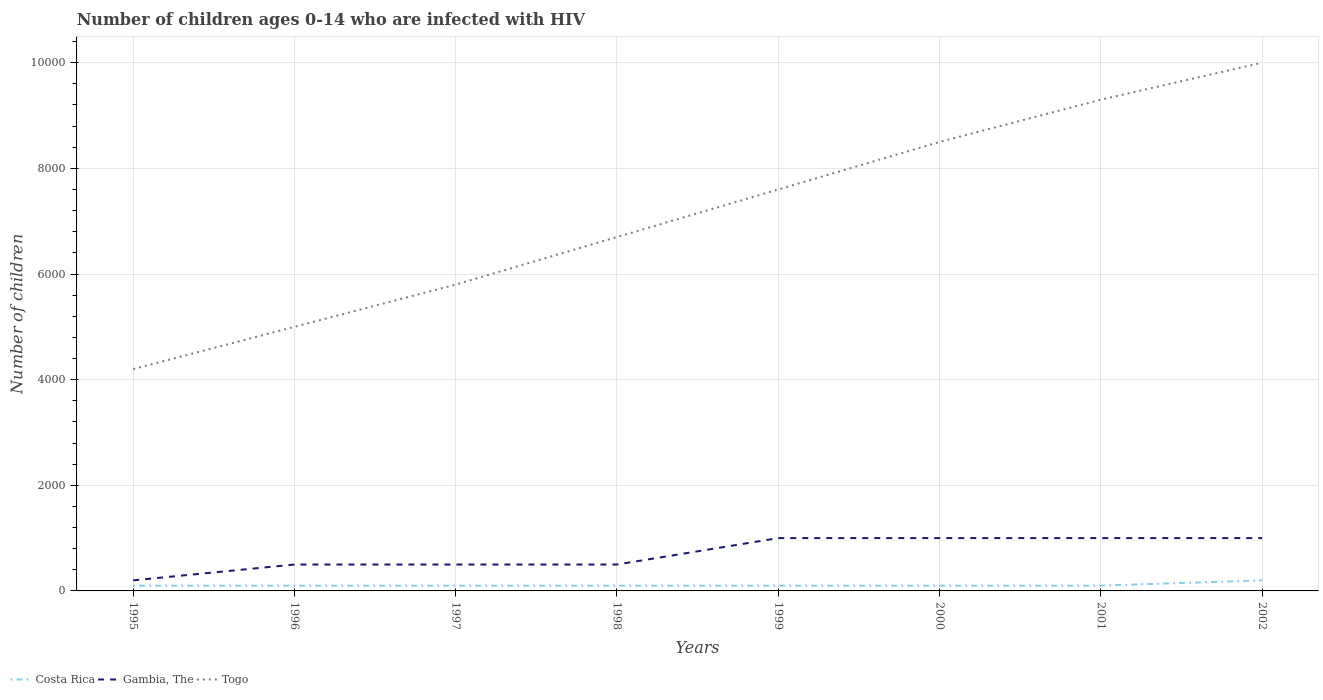How many different coloured lines are there?
Provide a succinct answer. 3. Does the line corresponding to Togo intersect with the line corresponding to Gambia, The?
Give a very brief answer. No. Is the number of lines equal to the number of legend labels?
Provide a short and direct response. Yes. Across all years, what is the maximum number of HIV infected children in Gambia, The?
Offer a very short reply. 200. What is the total number of HIV infected children in Gambia, The in the graph?
Offer a terse response. -300. What is the difference between the highest and the second highest number of HIV infected children in Costa Rica?
Keep it short and to the point. 100. Is the number of HIV infected children in Gambia, The strictly greater than the number of HIV infected children in Togo over the years?
Offer a very short reply. Yes. How many years are there in the graph?
Give a very brief answer. 8. Are the values on the major ticks of Y-axis written in scientific E-notation?
Provide a succinct answer. No. Does the graph contain any zero values?
Provide a short and direct response. No. Does the graph contain grids?
Make the answer very short. Yes. Where does the legend appear in the graph?
Keep it short and to the point. Bottom left. How many legend labels are there?
Make the answer very short. 3. How are the legend labels stacked?
Offer a very short reply. Horizontal. What is the title of the graph?
Ensure brevity in your answer.  Number of children ages 0-14 who are infected with HIV. What is the label or title of the Y-axis?
Ensure brevity in your answer.  Number of children. What is the Number of children in Togo in 1995?
Give a very brief answer. 4200. What is the Number of children of Costa Rica in 1996?
Provide a short and direct response. 100. What is the Number of children in Togo in 1996?
Make the answer very short. 5000. What is the Number of children of Togo in 1997?
Give a very brief answer. 5800. What is the Number of children of Costa Rica in 1998?
Your answer should be compact. 100. What is the Number of children of Gambia, The in 1998?
Provide a short and direct response. 500. What is the Number of children of Togo in 1998?
Your answer should be compact. 6700. What is the Number of children in Costa Rica in 1999?
Your response must be concise. 100. What is the Number of children of Gambia, The in 1999?
Keep it short and to the point. 1000. What is the Number of children of Togo in 1999?
Provide a succinct answer. 7600. What is the Number of children in Costa Rica in 2000?
Keep it short and to the point. 100. What is the Number of children in Gambia, The in 2000?
Offer a terse response. 1000. What is the Number of children of Togo in 2000?
Ensure brevity in your answer.  8500. What is the Number of children in Costa Rica in 2001?
Your answer should be very brief. 100. What is the Number of children in Togo in 2001?
Your response must be concise. 9300. What is the Number of children in Gambia, The in 2002?
Offer a terse response. 1000. Across all years, what is the maximum Number of children in Gambia, The?
Provide a short and direct response. 1000. Across all years, what is the maximum Number of children in Togo?
Ensure brevity in your answer.  10000. Across all years, what is the minimum Number of children of Costa Rica?
Provide a short and direct response. 100. Across all years, what is the minimum Number of children in Gambia, The?
Offer a terse response. 200. Across all years, what is the minimum Number of children in Togo?
Give a very brief answer. 4200. What is the total Number of children of Costa Rica in the graph?
Offer a very short reply. 900. What is the total Number of children in Gambia, The in the graph?
Offer a very short reply. 5700. What is the total Number of children in Togo in the graph?
Give a very brief answer. 5.71e+04. What is the difference between the Number of children of Gambia, The in 1995 and that in 1996?
Your answer should be very brief. -300. What is the difference between the Number of children in Togo in 1995 and that in 1996?
Your answer should be compact. -800. What is the difference between the Number of children in Costa Rica in 1995 and that in 1997?
Provide a succinct answer. 0. What is the difference between the Number of children in Gambia, The in 1995 and that in 1997?
Keep it short and to the point. -300. What is the difference between the Number of children in Togo in 1995 and that in 1997?
Offer a terse response. -1600. What is the difference between the Number of children in Gambia, The in 1995 and that in 1998?
Provide a short and direct response. -300. What is the difference between the Number of children in Togo in 1995 and that in 1998?
Keep it short and to the point. -2500. What is the difference between the Number of children in Costa Rica in 1995 and that in 1999?
Ensure brevity in your answer.  0. What is the difference between the Number of children in Gambia, The in 1995 and that in 1999?
Your answer should be compact. -800. What is the difference between the Number of children of Togo in 1995 and that in 1999?
Offer a very short reply. -3400. What is the difference between the Number of children in Costa Rica in 1995 and that in 2000?
Offer a terse response. 0. What is the difference between the Number of children of Gambia, The in 1995 and that in 2000?
Your response must be concise. -800. What is the difference between the Number of children of Togo in 1995 and that in 2000?
Provide a short and direct response. -4300. What is the difference between the Number of children in Costa Rica in 1995 and that in 2001?
Give a very brief answer. 0. What is the difference between the Number of children of Gambia, The in 1995 and that in 2001?
Your answer should be compact. -800. What is the difference between the Number of children of Togo in 1995 and that in 2001?
Your response must be concise. -5100. What is the difference between the Number of children of Costa Rica in 1995 and that in 2002?
Make the answer very short. -100. What is the difference between the Number of children of Gambia, The in 1995 and that in 2002?
Make the answer very short. -800. What is the difference between the Number of children in Togo in 1995 and that in 2002?
Offer a very short reply. -5800. What is the difference between the Number of children in Costa Rica in 1996 and that in 1997?
Make the answer very short. 0. What is the difference between the Number of children of Gambia, The in 1996 and that in 1997?
Make the answer very short. 0. What is the difference between the Number of children in Togo in 1996 and that in 1997?
Ensure brevity in your answer.  -800. What is the difference between the Number of children in Costa Rica in 1996 and that in 1998?
Offer a very short reply. 0. What is the difference between the Number of children of Togo in 1996 and that in 1998?
Make the answer very short. -1700. What is the difference between the Number of children of Costa Rica in 1996 and that in 1999?
Provide a succinct answer. 0. What is the difference between the Number of children in Gambia, The in 1996 and that in 1999?
Keep it short and to the point. -500. What is the difference between the Number of children in Togo in 1996 and that in 1999?
Your answer should be very brief. -2600. What is the difference between the Number of children in Costa Rica in 1996 and that in 2000?
Offer a terse response. 0. What is the difference between the Number of children of Gambia, The in 1996 and that in 2000?
Ensure brevity in your answer.  -500. What is the difference between the Number of children in Togo in 1996 and that in 2000?
Your answer should be compact. -3500. What is the difference between the Number of children of Gambia, The in 1996 and that in 2001?
Provide a short and direct response. -500. What is the difference between the Number of children of Togo in 1996 and that in 2001?
Provide a short and direct response. -4300. What is the difference between the Number of children of Costa Rica in 1996 and that in 2002?
Provide a short and direct response. -100. What is the difference between the Number of children of Gambia, The in 1996 and that in 2002?
Make the answer very short. -500. What is the difference between the Number of children in Togo in 1996 and that in 2002?
Your response must be concise. -5000. What is the difference between the Number of children in Togo in 1997 and that in 1998?
Make the answer very short. -900. What is the difference between the Number of children of Gambia, The in 1997 and that in 1999?
Your answer should be very brief. -500. What is the difference between the Number of children of Togo in 1997 and that in 1999?
Make the answer very short. -1800. What is the difference between the Number of children of Costa Rica in 1997 and that in 2000?
Make the answer very short. 0. What is the difference between the Number of children in Gambia, The in 1997 and that in 2000?
Provide a succinct answer. -500. What is the difference between the Number of children in Togo in 1997 and that in 2000?
Provide a succinct answer. -2700. What is the difference between the Number of children in Costa Rica in 1997 and that in 2001?
Offer a very short reply. 0. What is the difference between the Number of children of Gambia, The in 1997 and that in 2001?
Ensure brevity in your answer.  -500. What is the difference between the Number of children of Togo in 1997 and that in 2001?
Your answer should be very brief. -3500. What is the difference between the Number of children in Costa Rica in 1997 and that in 2002?
Your answer should be compact. -100. What is the difference between the Number of children in Gambia, The in 1997 and that in 2002?
Keep it short and to the point. -500. What is the difference between the Number of children of Togo in 1997 and that in 2002?
Provide a succinct answer. -4200. What is the difference between the Number of children in Gambia, The in 1998 and that in 1999?
Give a very brief answer. -500. What is the difference between the Number of children of Togo in 1998 and that in 1999?
Your response must be concise. -900. What is the difference between the Number of children in Gambia, The in 1998 and that in 2000?
Your answer should be compact. -500. What is the difference between the Number of children of Togo in 1998 and that in 2000?
Give a very brief answer. -1800. What is the difference between the Number of children in Gambia, The in 1998 and that in 2001?
Provide a succinct answer. -500. What is the difference between the Number of children of Togo in 1998 and that in 2001?
Provide a short and direct response. -2600. What is the difference between the Number of children of Costa Rica in 1998 and that in 2002?
Give a very brief answer. -100. What is the difference between the Number of children in Gambia, The in 1998 and that in 2002?
Provide a short and direct response. -500. What is the difference between the Number of children in Togo in 1998 and that in 2002?
Your response must be concise. -3300. What is the difference between the Number of children of Costa Rica in 1999 and that in 2000?
Keep it short and to the point. 0. What is the difference between the Number of children of Togo in 1999 and that in 2000?
Make the answer very short. -900. What is the difference between the Number of children of Costa Rica in 1999 and that in 2001?
Ensure brevity in your answer.  0. What is the difference between the Number of children in Togo in 1999 and that in 2001?
Make the answer very short. -1700. What is the difference between the Number of children of Costa Rica in 1999 and that in 2002?
Make the answer very short. -100. What is the difference between the Number of children in Gambia, The in 1999 and that in 2002?
Your response must be concise. 0. What is the difference between the Number of children of Togo in 1999 and that in 2002?
Provide a succinct answer. -2400. What is the difference between the Number of children in Gambia, The in 2000 and that in 2001?
Make the answer very short. 0. What is the difference between the Number of children of Togo in 2000 and that in 2001?
Your answer should be compact. -800. What is the difference between the Number of children in Costa Rica in 2000 and that in 2002?
Give a very brief answer. -100. What is the difference between the Number of children of Togo in 2000 and that in 2002?
Offer a terse response. -1500. What is the difference between the Number of children of Costa Rica in 2001 and that in 2002?
Ensure brevity in your answer.  -100. What is the difference between the Number of children in Togo in 2001 and that in 2002?
Offer a very short reply. -700. What is the difference between the Number of children in Costa Rica in 1995 and the Number of children in Gambia, The in 1996?
Your answer should be compact. -400. What is the difference between the Number of children in Costa Rica in 1995 and the Number of children in Togo in 1996?
Provide a short and direct response. -4900. What is the difference between the Number of children of Gambia, The in 1995 and the Number of children of Togo in 1996?
Offer a terse response. -4800. What is the difference between the Number of children in Costa Rica in 1995 and the Number of children in Gambia, The in 1997?
Offer a terse response. -400. What is the difference between the Number of children of Costa Rica in 1995 and the Number of children of Togo in 1997?
Make the answer very short. -5700. What is the difference between the Number of children of Gambia, The in 1995 and the Number of children of Togo in 1997?
Offer a terse response. -5600. What is the difference between the Number of children in Costa Rica in 1995 and the Number of children in Gambia, The in 1998?
Keep it short and to the point. -400. What is the difference between the Number of children in Costa Rica in 1995 and the Number of children in Togo in 1998?
Your answer should be very brief. -6600. What is the difference between the Number of children in Gambia, The in 1995 and the Number of children in Togo in 1998?
Your answer should be compact. -6500. What is the difference between the Number of children of Costa Rica in 1995 and the Number of children of Gambia, The in 1999?
Your answer should be very brief. -900. What is the difference between the Number of children of Costa Rica in 1995 and the Number of children of Togo in 1999?
Keep it short and to the point. -7500. What is the difference between the Number of children of Gambia, The in 1995 and the Number of children of Togo in 1999?
Provide a succinct answer. -7400. What is the difference between the Number of children of Costa Rica in 1995 and the Number of children of Gambia, The in 2000?
Make the answer very short. -900. What is the difference between the Number of children in Costa Rica in 1995 and the Number of children in Togo in 2000?
Make the answer very short. -8400. What is the difference between the Number of children in Gambia, The in 1995 and the Number of children in Togo in 2000?
Keep it short and to the point. -8300. What is the difference between the Number of children of Costa Rica in 1995 and the Number of children of Gambia, The in 2001?
Your response must be concise. -900. What is the difference between the Number of children in Costa Rica in 1995 and the Number of children in Togo in 2001?
Provide a succinct answer. -9200. What is the difference between the Number of children in Gambia, The in 1995 and the Number of children in Togo in 2001?
Make the answer very short. -9100. What is the difference between the Number of children in Costa Rica in 1995 and the Number of children in Gambia, The in 2002?
Make the answer very short. -900. What is the difference between the Number of children of Costa Rica in 1995 and the Number of children of Togo in 2002?
Ensure brevity in your answer.  -9900. What is the difference between the Number of children of Gambia, The in 1995 and the Number of children of Togo in 2002?
Your response must be concise. -9800. What is the difference between the Number of children of Costa Rica in 1996 and the Number of children of Gambia, The in 1997?
Provide a succinct answer. -400. What is the difference between the Number of children in Costa Rica in 1996 and the Number of children in Togo in 1997?
Your answer should be very brief. -5700. What is the difference between the Number of children of Gambia, The in 1996 and the Number of children of Togo in 1997?
Keep it short and to the point. -5300. What is the difference between the Number of children of Costa Rica in 1996 and the Number of children of Gambia, The in 1998?
Provide a succinct answer. -400. What is the difference between the Number of children of Costa Rica in 1996 and the Number of children of Togo in 1998?
Make the answer very short. -6600. What is the difference between the Number of children in Gambia, The in 1996 and the Number of children in Togo in 1998?
Ensure brevity in your answer.  -6200. What is the difference between the Number of children in Costa Rica in 1996 and the Number of children in Gambia, The in 1999?
Keep it short and to the point. -900. What is the difference between the Number of children of Costa Rica in 1996 and the Number of children of Togo in 1999?
Your response must be concise. -7500. What is the difference between the Number of children in Gambia, The in 1996 and the Number of children in Togo in 1999?
Give a very brief answer. -7100. What is the difference between the Number of children in Costa Rica in 1996 and the Number of children in Gambia, The in 2000?
Offer a terse response. -900. What is the difference between the Number of children in Costa Rica in 1996 and the Number of children in Togo in 2000?
Provide a succinct answer. -8400. What is the difference between the Number of children in Gambia, The in 1996 and the Number of children in Togo in 2000?
Your answer should be very brief. -8000. What is the difference between the Number of children of Costa Rica in 1996 and the Number of children of Gambia, The in 2001?
Make the answer very short. -900. What is the difference between the Number of children of Costa Rica in 1996 and the Number of children of Togo in 2001?
Your answer should be compact. -9200. What is the difference between the Number of children of Gambia, The in 1996 and the Number of children of Togo in 2001?
Your response must be concise. -8800. What is the difference between the Number of children in Costa Rica in 1996 and the Number of children in Gambia, The in 2002?
Offer a terse response. -900. What is the difference between the Number of children in Costa Rica in 1996 and the Number of children in Togo in 2002?
Ensure brevity in your answer.  -9900. What is the difference between the Number of children of Gambia, The in 1996 and the Number of children of Togo in 2002?
Ensure brevity in your answer.  -9500. What is the difference between the Number of children in Costa Rica in 1997 and the Number of children in Gambia, The in 1998?
Give a very brief answer. -400. What is the difference between the Number of children in Costa Rica in 1997 and the Number of children in Togo in 1998?
Make the answer very short. -6600. What is the difference between the Number of children in Gambia, The in 1997 and the Number of children in Togo in 1998?
Provide a succinct answer. -6200. What is the difference between the Number of children in Costa Rica in 1997 and the Number of children in Gambia, The in 1999?
Offer a terse response. -900. What is the difference between the Number of children in Costa Rica in 1997 and the Number of children in Togo in 1999?
Provide a short and direct response. -7500. What is the difference between the Number of children in Gambia, The in 1997 and the Number of children in Togo in 1999?
Your answer should be very brief. -7100. What is the difference between the Number of children of Costa Rica in 1997 and the Number of children of Gambia, The in 2000?
Provide a succinct answer. -900. What is the difference between the Number of children in Costa Rica in 1997 and the Number of children in Togo in 2000?
Your response must be concise. -8400. What is the difference between the Number of children in Gambia, The in 1997 and the Number of children in Togo in 2000?
Give a very brief answer. -8000. What is the difference between the Number of children in Costa Rica in 1997 and the Number of children in Gambia, The in 2001?
Keep it short and to the point. -900. What is the difference between the Number of children of Costa Rica in 1997 and the Number of children of Togo in 2001?
Your answer should be very brief. -9200. What is the difference between the Number of children in Gambia, The in 1997 and the Number of children in Togo in 2001?
Ensure brevity in your answer.  -8800. What is the difference between the Number of children of Costa Rica in 1997 and the Number of children of Gambia, The in 2002?
Keep it short and to the point. -900. What is the difference between the Number of children of Costa Rica in 1997 and the Number of children of Togo in 2002?
Offer a terse response. -9900. What is the difference between the Number of children of Gambia, The in 1997 and the Number of children of Togo in 2002?
Your answer should be very brief. -9500. What is the difference between the Number of children in Costa Rica in 1998 and the Number of children in Gambia, The in 1999?
Keep it short and to the point. -900. What is the difference between the Number of children in Costa Rica in 1998 and the Number of children in Togo in 1999?
Provide a short and direct response. -7500. What is the difference between the Number of children of Gambia, The in 1998 and the Number of children of Togo in 1999?
Ensure brevity in your answer.  -7100. What is the difference between the Number of children of Costa Rica in 1998 and the Number of children of Gambia, The in 2000?
Provide a succinct answer. -900. What is the difference between the Number of children in Costa Rica in 1998 and the Number of children in Togo in 2000?
Offer a very short reply. -8400. What is the difference between the Number of children of Gambia, The in 1998 and the Number of children of Togo in 2000?
Provide a succinct answer. -8000. What is the difference between the Number of children of Costa Rica in 1998 and the Number of children of Gambia, The in 2001?
Offer a very short reply. -900. What is the difference between the Number of children of Costa Rica in 1998 and the Number of children of Togo in 2001?
Make the answer very short. -9200. What is the difference between the Number of children in Gambia, The in 1998 and the Number of children in Togo in 2001?
Your answer should be compact. -8800. What is the difference between the Number of children in Costa Rica in 1998 and the Number of children in Gambia, The in 2002?
Provide a short and direct response. -900. What is the difference between the Number of children of Costa Rica in 1998 and the Number of children of Togo in 2002?
Give a very brief answer. -9900. What is the difference between the Number of children in Gambia, The in 1998 and the Number of children in Togo in 2002?
Keep it short and to the point. -9500. What is the difference between the Number of children of Costa Rica in 1999 and the Number of children of Gambia, The in 2000?
Your answer should be very brief. -900. What is the difference between the Number of children of Costa Rica in 1999 and the Number of children of Togo in 2000?
Ensure brevity in your answer.  -8400. What is the difference between the Number of children of Gambia, The in 1999 and the Number of children of Togo in 2000?
Offer a terse response. -7500. What is the difference between the Number of children in Costa Rica in 1999 and the Number of children in Gambia, The in 2001?
Offer a terse response. -900. What is the difference between the Number of children in Costa Rica in 1999 and the Number of children in Togo in 2001?
Keep it short and to the point. -9200. What is the difference between the Number of children in Gambia, The in 1999 and the Number of children in Togo in 2001?
Ensure brevity in your answer.  -8300. What is the difference between the Number of children in Costa Rica in 1999 and the Number of children in Gambia, The in 2002?
Your answer should be compact. -900. What is the difference between the Number of children in Costa Rica in 1999 and the Number of children in Togo in 2002?
Ensure brevity in your answer.  -9900. What is the difference between the Number of children of Gambia, The in 1999 and the Number of children of Togo in 2002?
Your answer should be compact. -9000. What is the difference between the Number of children in Costa Rica in 2000 and the Number of children in Gambia, The in 2001?
Give a very brief answer. -900. What is the difference between the Number of children in Costa Rica in 2000 and the Number of children in Togo in 2001?
Offer a terse response. -9200. What is the difference between the Number of children of Gambia, The in 2000 and the Number of children of Togo in 2001?
Offer a terse response. -8300. What is the difference between the Number of children in Costa Rica in 2000 and the Number of children in Gambia, The in 2002?
Provide a succinct answer. -900. What is the difference between the Number of children of Costa Rica in 2000 and the Number of children of Togo in 2002?
Ensure brevity in your answer.  -9900. What is the difference between the Number of children of Gambia, The in 2000 and the Number of children of Togo in 2002?
Give a very brief answer. -9000. What is the difference between the Number of children of Costa Rica in 2001 and the Number of children of Gambia, The in 2002?
Offer a terse response. -900. What is the difference between the Number of children of Costa Rica in 2001 and the Number of children of Togo in 2002?
Provide a short and direct response. -9900. What is the difference between the Number of children of Gambia, The in 2001 and the Number of children of Togo in 2002?
Give a very brief answer. -9000. What is the average Number of children in Costa Rica per year?
Offer a very short reply. 112.5. What is the average Number of children in Gambia, The per year?
Provide a succinct answer. 712.5. What is the average Number of children in Togo per year?
Offer a terse response. 7137.5. In the year 1995, what is the difference between the Number of children in Costa Rica and Number of children in Gambia, The?
Ensure brevity in your answer.  -100. In the year 1995, what is the difference between the Number of children of Costa Rica and Number of children of Togo?
Provide a short and direct response. -4100. In the year 1995, what is the difference between the Number of children in Gambia, The and Number of children in Togo?
Keep it short and to the point. -4000. In the year 1996, what is the difference between the Number of children of Costa Rica and Number of children of Gambia, The?
Keep it short and to the point. -400. In the year 1996, what is the difference between the Number of children in Costa Rica and Number of children in Togo?
Provide a succinct answer. -4900. In the year 1996, what is the difference between the Number of children of Gambia, The and Number of children of Togo?
Make the answer very short. -4500. In the year 1997, what is the difference between the Number of children in Costa Rica and Number of children in Gambia, The?
Your answer should be compact. -400. In the year 1997, what is the difference between the Number of children in Costa Rica and Number of children in Togo?
Make the answer very short. -5700. In the year 1997, what is the difference between the Number of children of Gambia, The and Number of children of Togo?
Provide a succinct answer. -5300. In the year 1998, what is the difference between the Number of children of Costa Rica and Number of children of Gambia, The?
Keep it short and to the point. -400. In the year 1998, what is the difference between the Number of children in Costa Rica and Number of children in Togo?
Provide a short and direct response. -6600. In the year 1998, what is the difference between the Number of children in Gambia, The and Number of children in Togo?
Offer a very short reply. -6200. In the year 1999, what is the difference between the Number of children in Costa Rica and Number of children in Gambia, The?
Your response must be concise. -900. In the year 1999, what is the difference between the Number of children of Costa Rica and Number of children of Togo?
Offer a terse response. -7500. In the year 1999, what is the difference between the Number of children in Gambia, The and Number of children in Togo?
Make the answer very short. -6600. In the year 2000, what is the difference between the Number of children of Costa Rica and Number of children of Gambia, The?
Make the answer very short. -900. In the year 2000, what is the difference between the Number of children in Costa Rica and Number of children in Togo?
Offer a very short reply. -8400. In the year 2000, what is the difference between the Number of children of Gambia, The and Number of children of Togo?
Provide a short and direct response. -7500. In the year 2001, what is the difference between the Number of children in Costa Rica and Number of children in Gambia, The?
Keep it short and to the point. -900. In the year 2001, what is the difference between the Number of children in Costa Rica and Number of children in Togo?
Provide a short and direct response. -9200. In the year 2001, what is the difference between the Number of children in Gambia, The and Number of children in Togo?
Offer a terse response. -8300. In the year 2002, what is the difference between the Number of children of Costa Rica and Number of children of Gambia, The?
Give a very brief answer. -800. In the year 2002, what is the difference between the Number of children in Costa Rica and Number of children in Togo?
Give a very brief answer. -9800. In the year 2002, what is the difference between the Number of children of Gambia, The and Number of children of Togo?
Your response must be concise. -9000. What is the ratio of the Number of children in Costa Rica in 1995 to that in 1996?
Offer a terse response. 1. What is the ratio of the Number of children of Gambia, The in 1995 to that in 1996?
Offer a very short reply. 0.4. What is the ratio of the Number of children in Togo in 1995 to that in 1996?
Keep it short and to the point. 0.84. What is the ratio of the Number of children in Costa Rica in 1995 to that in 1997?
Ensure brevity in your answer.  1. What is the ratio of the Number of children of Gambia, The in 1995 to that in 1997?
Provide a succinct answer. 0.4. What is the ratio of the Number of children in Togo in 1995 to that in 1997?
Provide a short and direct response. 0.72. What is the ratio of the Number of children in Costa Rica in 1995 to that in 1998?
Your answer should be very brief. 1. What is the ratio of the Number of children of Gambia, The in 1995 to that in 1998?
Ensure brevity in your answer.  0.4. What is the ratio of the Number of children in Togo in 1995 to that in 1998?
Your answer should be compact. 0.63. What is the ratio of the Number of children of Gambia, The in 1995 to that in 1999?
Keep it short and to the point. 0.2. What is the ratio of the Number of children of Togo in 1995 to that in 1999?
Provide a succinct answer. 0.55. What is the ratio of the Number of children of Gambia, The in 1995 to that in 2000?
Provide a succinct answer. 0.2. What is the ratio of the Number of children in Togo in 1995 to that in 2000?
Your answer should be compact. 0.49. What is the ratio of the Number of children of Costa Rica in 1995 to that in 2001?
Offer a very short reply. 1. What is the ratio of the Number of children of Gambia, The in 1995 to that in 2001?
Your response must be concise. 0.2. What is the ratio of the Number of children of Togo in 1995 to that in 2001?
Provide a succinct answer. 0.45. What is the ratio of the Number of children of Costa Rica in 1995 to that in 2002?
Keep it short and to the point. 0.5. What is the ratio of the Number of children of Togo in 1995 to that in 2002?
Keep it short and to the point. 0.42. What is the ratio of the Number of children of Togo in 1996 to that in 1997?
Give a very brief answer. 0.86. What is the ratio of the Number of children of Costa Rica in 1996 to that in 1998?
Keep it short and to the point. 1. What is the ratio of the Number of children in Gambia, The in 1996 to that in 1998?
Your answer should be very brief. 1. What is the ratio of the Number of children of Togo in 1996 to that in 1998?
Your answer should be very brief. 0.75. What is the ratio of the Number of children in Gambia, The in 1996 to that in 1999?
Give a very brief answer. 0.5. What is the ratio of the Number of children of Togo in 1996 to that in 1999?
Offer a terse response. 0.66. What is the ratio of the Number of children of Gambia, The in 1996 to that in 2000?
Provide a short and direct response. 0.5. What is the ratio of the Number of children in Togo in 1996 to that in 2000?
Provide a succinct answer. 0.59. What is the ratio of the Number of children of Costa Rica in 1996 to that in 2001?
Make the answer very short. 1. What is the ratio of the Number of children of Togo in 1996 to that in 2001?
Keep it short and to the point. 0.54. What is the ratio of the Number of children in Gambia, The in 1996 to that in 2002?
Provide a succinct answer. 0.5. What is the ratio of the Number of children of Togo in 1996 to that in 2002?
Keep it short and to the point. 0.5. What is the ratio of the Number of children of Gambia, The in 1997 to that in 1998?
Ensure brevity in your answer.  1. What is the ratio of the Number of children of Togo in 1997 to that in 1998?
Provide a short and direct response. 0.87. What is the ratio of the Number of children in Togo in 1997 to that in 1999?
Give a very brief answer. 0.76. What is the ratio of the Number of children in Togo in 1997 to that in 2000?
Your answer should be compact. 0.68. What is the ratio of the Number of children of Costa Rica in 1997 to that in 2001?
Ensure brevity in your answer.  1. What is the ratio of the Number of children in Gambia, The in 1997 to that in 2001?
Give a very brief answer. 0.5. What is the ratio of the Number of children in Togo in 1997 to that in 2001?
Offer a terse response. 0.62. What is the ratio of the Number of children in Togo in 1997 to that in 2002?
Make the answer very short. 0.58. What is the ratio of the Number of children of Costa Rica in 1998 to that in 1999?
Provide a short and direct response. 1. What is the ratio of the Number of children in Gambia, The in 1998 to that in 1999?
Your response must be concise. 0.5. What is the ratio of the Number of children in Togo in 1998 to that in 1999?
Make the answer very short. 0.88. What is the ratio of the Number of children in Gambia, The in 1998 to that in 2000?
Offer a terse response. 0.5. What is the ratio of the Number of children of Togo in 1998 to that in 2000?
Keep it short and to the point. 0.79. What is the ratio of the Number of children of Togo in 1998 to that in 2001?
Offer a very short reply. 0.72. What is the ratio of the Number of children of Togo in 1998 to that in 2002?
Provide a short and direct response. 0.67. What is the ratio of the Number of children in Costa Rica in 1999 to that in 2000?
Keep it short and to the point. 1. What is the ratio of the Number of children of Gambia, The in 1999 to that in 2000?
Your response must be concise. 1. What is the ratio of the Number of children of Togo in 1999 to that in 2000?
Provide a succinct answer. 0.89. What is the ratio of the Number of children of Togo in 1999 to that in 2001?
Your answer should be compact. 0.82. What is the ratio of the Number of children in Costa Rica in 1999 to that in 2002?
Your answer should be very brief. 0.5. What is the ratio of the Number of children in Togo in 1999 to that in 2002?
Give a very brief answer. 0.76. What is the ratio of the Number of children in Costa Rica in 2000 to that in 2001?
Provide a succinct answer. 1. What is the ratio of the Number of children in Gambia, The in 2000 to that in 2001?
Your answer should be very brief. 1. What is the ratio of the Number of children in Togo in 2000 to that in 2001?
Make the answer very short. 0.91. What is the ratio of the Number of children in Costa Rica in 2000 to that in 2002?
Provide a short and direct response. 0.5. What is the ratio of the Number of children in Gambia, The in 2000 to that in 2002?
Offer a terse response. 1. What is the ratio of the Number of children in Costa Rica in 2001 to that in 2002?
Offer a very short reply. 0.5. What is the difference between the highest and the second highest Number of children of Gambia, The?
Your answer should be compact. 0. What is the difference between the highest and the second highest Number of children in Togo?
Offer a very short reply. 700. What is the difference between the highest and the lowest Number of children in Gambia, The?
Your answer should be very brief. 800. What is the difference between the highest and the lowest Number of children in Togo?
Ensure brevity in your answer.  5800. 